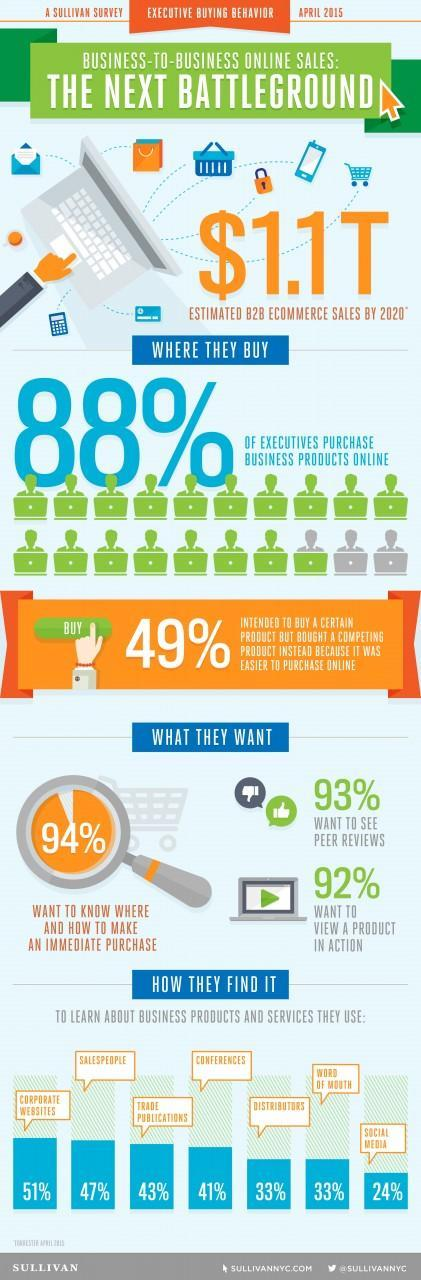What percent of executives do not want to see peer reviews according to a Sullivan survey of executive buying behavior in April 2015?
Answer the question with a short phrase. 7% What do most of the executives prefer to use in order to learn about business products & services according to a Sullivan survey of executive buying behavior in April 2015? CORPORATE WEBSITES What percent of executives use conferences to learn about business products & services according to a Sullivan survey of executive buying behavior in April 2015? 41% What percent of executives use social media to learn about business products & services according to a Sullivan survey of executive buying behavior in April 2015? 24% What percent of executives do not purchase business products online according to a Sullivan survey of executive buying behavior in April 2015? 12% What percent of executives do not want to view a product in action according to a Sullivan survey of executive buying behavior in April 2015? 8% 